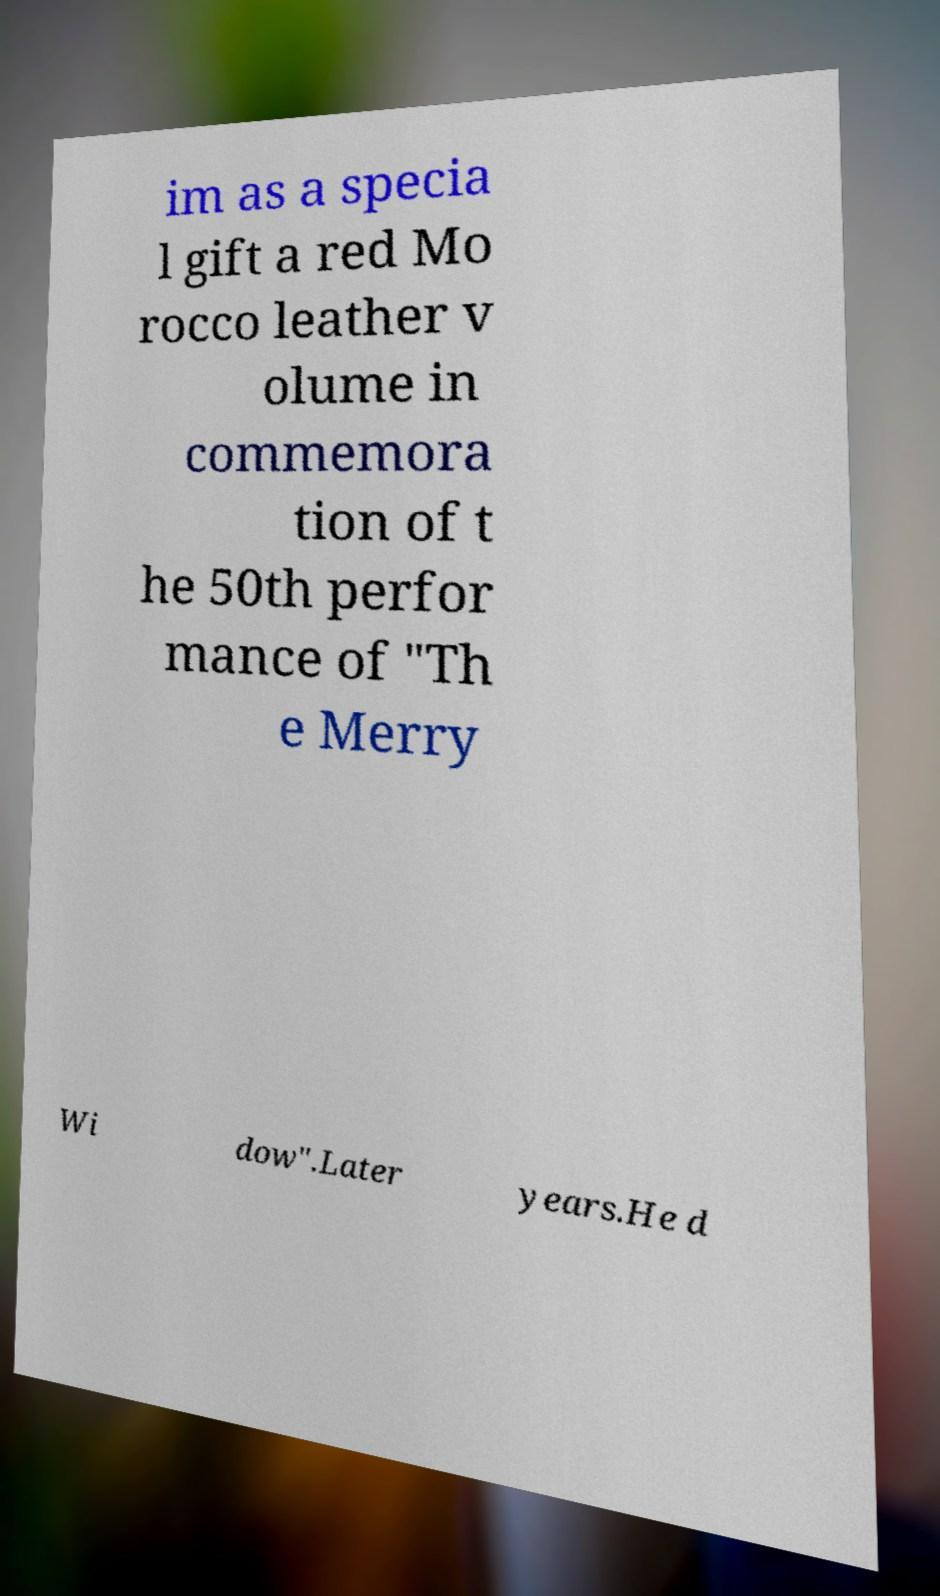Can you read and provide the text displayed in the image?This photo seems to have some interesting text. Can you extract and type it out for me? im as a specia l gift a red Mo rocco leather v olume in commemora tion of t he 50th perfor mance of "Th e Merry Wi dow".Later years.He d 